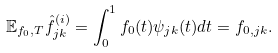<formula> <loc_0><loc_0><loc_500><loc_500>\mathbb { E } _ { f _ { 0 } , T } \hat { f } _ { j k } ^ { ( i ) } = \int _ { 0 } ^ { 1 } f _ { 0 } ( t ) \psi _ { j k } ( t ) d t = f _ { 0 , j k } .</formula> 